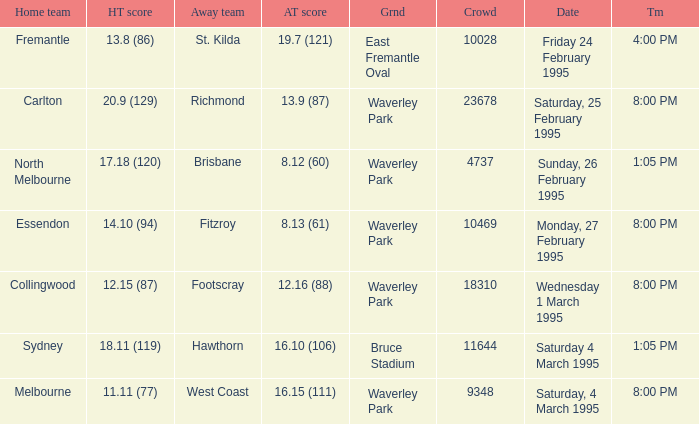Name the ground for essendon Waverley Park. 